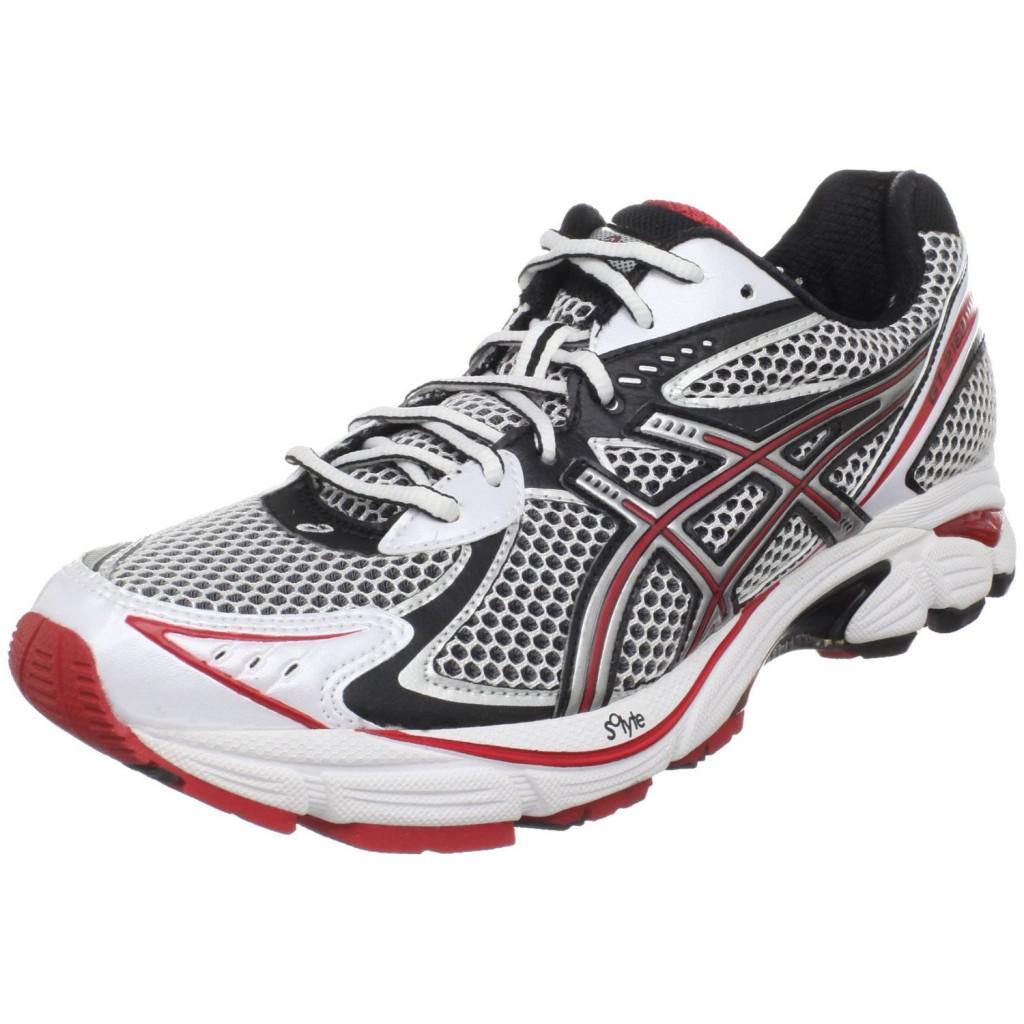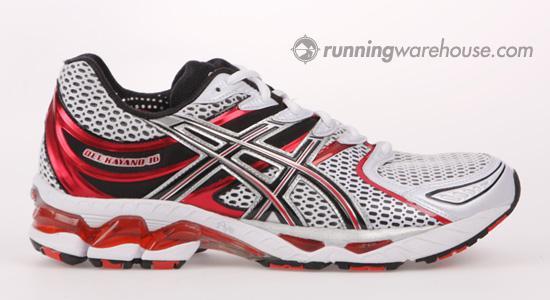The first image is the image on the left, the second image is the image on the right. Evaluate the accuracy of this statement regarding the images: "There is no more than one tennis shoe in the left image.". Is it true? Answer yes or no. Yes. The first image is the image on the left, the second image is the image on the right. For the images shown, is this caption "At least one image shows a pair of shoes that lacks the color red." true? Answer yes or no. No. 